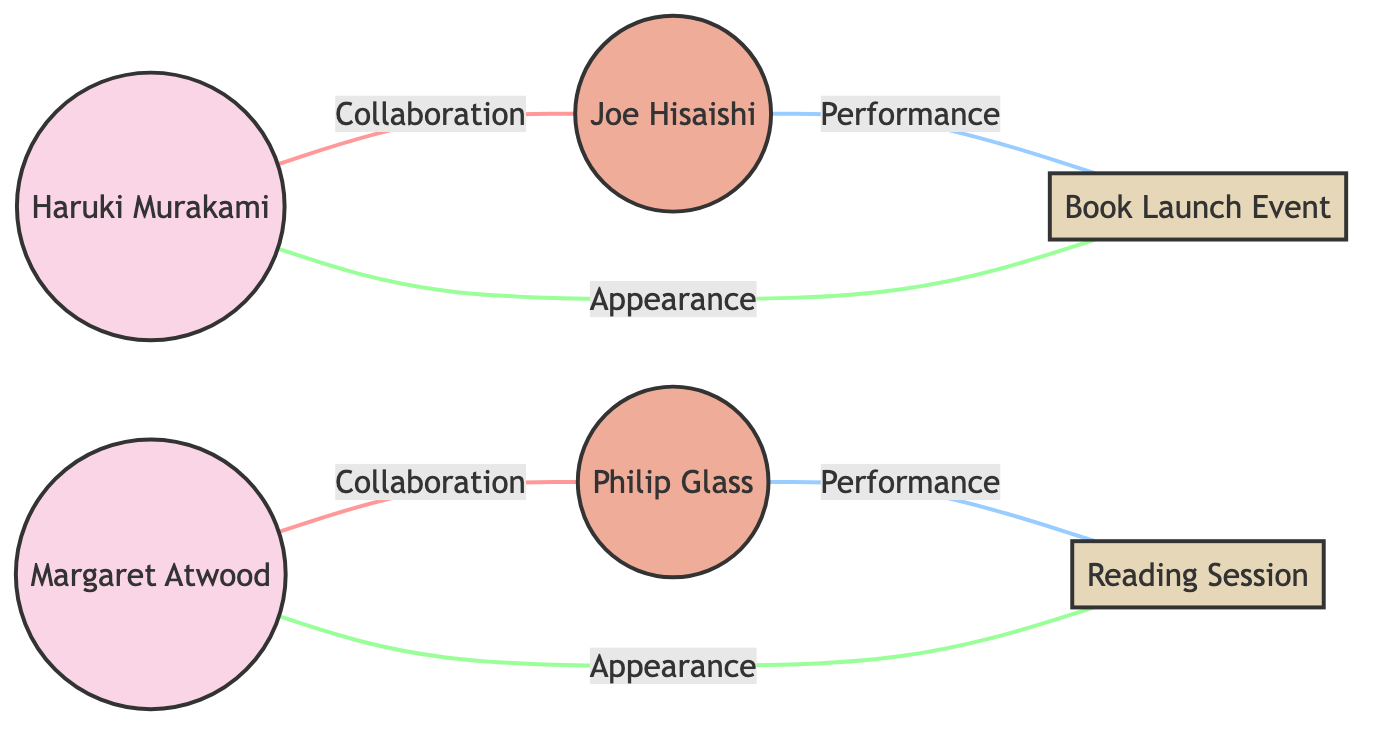What is the total number of nodes in the diagram? The diagram includes six distinct nodes: two novelists (Haruki Murakami and Margaret Atwood), two composers (Joe Hisaishi and Philip Glass), and two events (Book Launch Event and Reading Session). Counting these gives a total of six nodes.
Answer: 6 Who collaborates with Haruki Murakami? Haruki Murakami collaborates with Joe Hisaishi, as indicated by the edge labeled "Collaboration" connecting the two nodes.
Answer: Joe Hisaishi How many performance events are shown in the diagram? There are two edges labeled "Performance" in the diagram, one connecting Joe Hisaishi to the Book Launch Event and another connecting Philip Glass to the Reading Session. This indicates two performance events.
Answer: 2 What type of relationship exists between Philip Glass and the Reading Session? The relationship between Philip Glass and the Reading Session is described as "Performance" in the diagram, which indicates that Philip Glass composes or performs music for this event.
Answer: Performance Which novelist is associated with the Book Launch Event? The edge labeled "Appearance" from Haruki Murakami to the Book Launch Event indicates that Haruki Murakami is associated with this event.
Answer: Haruki Murakami How many collaborations are depicted in the diagram? The diagram shows two collaborations: one between Haruki Murakami and Joe Hisaishi, and another between Margaret Atwood and Philip Glass. Therefore, there are two collaborations depicted.
Answer: 2 What role does Joe Hisaishi have in relation to Haruki Murakami? Joe Hisaishi has a role of "Collaboration" with Haruki Murakami, meaning they work together on projects, specifically for a book launch music in this context.
Answer: Collaboration Which event does Margaret Atwood appear in? Margaret Atwood appears in the Reading Session, as indicated by the edge labeled "Appearance" connecting her to that event.
Answer: Reading Session What is the relationship between Margaret Atwood and Philip Glass? The relationship between Margaret Atwood and Philip Glass is also described as "Collaboration," indicating they work together for the reading sessions.
Answer: Collaboration 